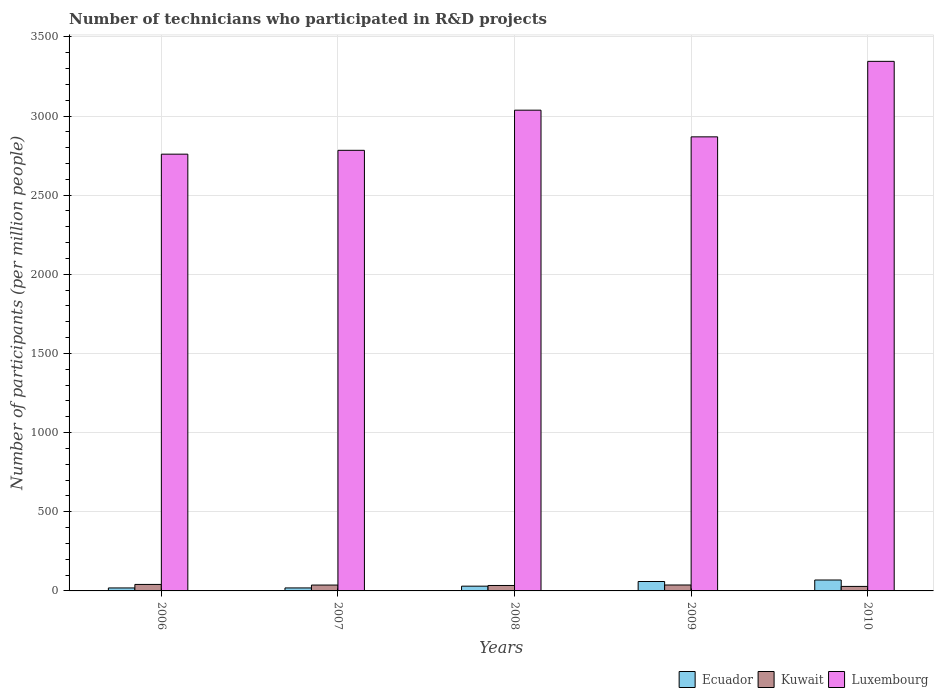How many groups of bars are there?
Provide a short and direct response. 5. What is the number of technicians who participated in R&D projects in Kuwait in 2010?
Offer a very short reply. 28.44. Across all years, what is the maximum number of technicians who participated in R&D projects in Kuwait?
Keep it short and to the point. 41.01. Across all years, what is the minimum number of technicians who participated in R&D projects in Ecuador?
Your response must be concise. 18.83. What is the total number of technicians who participated in R&D projects in Ecuador in the graph?
Your answer should be compact. 196.16. What is the difference between the number of technicians who participated in R&D projects in Luxembourg in 2007 and that in 2008?
Provide a short and direct response. -253.62. What is the difference between the number of technicians who participated in R&D projects in Ecuador in 2008 and the number of technicians who participated in R&D projects in Luxembourg in 2006?
Offer a very short reply. -2728.86. What is the average number of technicians who participated in R&D projects in Kuwait per year?
Provide a short and direct response. 35.67. In the year 2008, what is the difference between the number of technicians who participated in R&D projects in Kuwait and number of technicians who participated in R&D projects in Luxembourg?
Keep it short and to the point. -3002.45. What is the ratio of the number of technicians who participated in R&D projects in Kuwait in 2006 to that in 2007?
Keep it short and to the point. 1.11. Is the difference between the number of technicians who participated in R&D projects in Kuwait in 2008 and 2010 greater than the difference between the number of technicians who participated in R&D projects in Luxembourg in 2008 and 2010?
Provide a short and direct response. Yes. What is the difference between the highest and the second highest number of technicians who participated in R&D projects in Ecuador?
Give a very brief answer. 9.47. What is the difference between the highest and the lowest number of technicians who participated in R&D projects in Kuwait?
Offer a terse response. 12.58. Is the sum of the number of technicians who participated in R&D projects in Luxembourg in 2007 and 2008 greater than the maximum number of technicians who participated in R&D projects in Kuwait across all years?
Make the answer very short. Yes. What does the 3rd bar from the left in 2010 represents?
Make the answer very short. Luxembourg. What does the 1st bar from the right in 2010 represents?
Provide a succinct answer. Luxembourg. Is it the case that in every year, the sum of the number of technicians who participated in R&D projects in Luxembourg and number of technicians who participated in R&D projects in Ecuador is greater than the number of technicians who participated in R&D projects in Kuwait?
Provide a succinct answer. Yes. How many bars are there?
Your response must be concise. 15. Are all the bars in the graph horizontal?
Your response must be concise. No. How many years are there in the graph?
Your answer should be compact. 5. Are the values on the major ticks of Y-axis written in scientific E-notation?
Keep it short and to the point. No. Does the graph contain any zero values?
Your answer should be very brief. No. Where does the legend appear in the graph?
Ensure brevity in your answer.  Bottom right. What is the title of the graph?
Offer a very short reply. Number of technicians who participated in R&D projects. What is the label or title of the Y-axis?
Offer a terse response. Number of participants (per million people). What is the Number of participants (per million people) in Ecuador in 2006?
Your response must be concise. 18.83. What is the Number of participants (per million people) of Kuwait in 2006?
Offer a terse response. 41.01. What is the Number of participants (per million people) in Luxembourg in 2006?
Offer a terse response. 2758.91. What is the Number of participants (per million people) in Ecuador in 2007?
Provide a succinct answer. 18.94. What is the Number of participants (per million people) of Kuwait in 2007?
Your answer should be compact. 37.03. What is the Number of participants (per million people) in Luxembourg in 2007?
Provide a short and direct response. 2783.2. What is the Number of participants (per million people) in Ecuador in 2008?
Offer a very short reply. 30.05. What is the Number of participants (per million people) of Kuwait in 2008?
Provide a short and direct response. 34.38. What is the Number of participants (per million people) in Luxembourg in 2008?
Ensure brevity in your answer.  3036.82. What is the Number of participants (per million people) in Ecuador in 2009?
Offer a very short reply. 59.44. What is the Number of participants (per million people) of Kuwait in 2009?
Offer a very short reply. 37.48. What is the Number of participants (per million people) of Luxembourg in 2009?
Provide a short and direct response. 2868.27. What is the Number of participants (per million people) of Ecuador in 2010?
Offer a very short reply. 68.91. What is the Number of participants (per million people) in Kuwait in 2010?
Give a very brief answer. 28.44. What is the Number of participants (per million people) in Luxembourg in 2010?
Provide a short and direct response. 3345.22. Across all years, what is the maximum Number of participants (per million people) of Ecuador?
Your answer should be compact. 68.91. Across all years, what is the maximum Number of participants (per million people) in Kuwait?
Your response must be concise. 41.01. Across all years, what is the maximum Number of participants (per million people) in Luxembourg?
Ensure brevity in your answer.  3345.22. Across all years, what is the minimum Number of participants (per million people) of Ecuador?
Give a very brief answer. 18.83. Across all years, what is the minimum Number of participants (per million people) in Kuwait?
Provide a short and direct response. 28.44. Across all years, what is the minimum Number of participants (per million people) of Luxembourg?
Provide a succinct answer. 2758.91. What is the total Number of participants (per million people) of Ecuador in the graph?
Your answer should be very brief. 196.16. What is the total Number of participants (per million people) in Kuwait in the graph?
Provide a succinct answer. 178.34. What is the total Number of participants (per million people) in Luxembourg in the graph?
Offer a very short reply. 1.48e+04. What is the difference between the Number of participants (per million people) of Ecuador in 2006 and that in 2007?
Offer a terse response. -0.11. What is the difference between the Number of participants (per million people) in Kuwait in 2006 and that in 2007?
Provide a succinct answer. 3.98. What is the difference between the Number of participants (per million people) in Luxembourg in 2006 and that in 2007?
Keep it short and to the point. -24.29. What is the difference between the Number of participants (per million people) in Ecuador in 2006 and that in 2008?
Your answer should be compact. -11.22. What is the difference between the Number of participants (per million people) in Kuwait in 2006 and that in 2008?
Provide a short and direct response. 6.64. What is the difference between the Number of participants (per million people) in Luxembourg in 2006 and that in 2008?
Your response must be concise. -277.91. What is the difference between the Number of participants (per million people) in Ecuador in 2006 and that in 2009?
Offer a very short reply. -40.61. What is the difference between the Number of participants (per million people) of Kuwait in 2006 and that in 2009?
Your answer should be very brief. 3.53. What is the difference between the Number of participants (per million people) in Luxembourg in 2006 and that in 2009?
Ensure brevity in your answer.  -109.36. What is the difference between the Number of participants (per million people) in Ecuador in 2006 and that in 2010?
Offer a terse response. -50.08. What is the difference between the Number of participants (per million people) in Kuwait in 2006 and that in 2010?
Your answer should be compact. 12.58. What is the difference between the Number of participants (per million people) in Luxembourg in 2006 and that in 2010?
Provide a succinct answer. -586.31. What is the difference between the Number of participants (per million people) of Ecuador in 2007 and that in 2008?
Offer a terse response. -11.12. What is the difference between the Number of participants (per million people) of Kuwait in 2007 and that in 2008?
Provide a short and direct response. 2.65. What is the difference between the Number of participants (per million people) of Luxembourg in 2007 and that in 2008?
Provide a succinct answer. -253.62. What is the difference between the Number of participants (per million people) in Ecuador in 2007 and that in 2009?
Your answer should be compact. -40.5. What is the difference between the Number of participants (per million people) of Kuwait in 2007 and that in 2009?
Provide a succinct answer. -0.46. What is the difference between the Number of participants (per million people) in Luxembourg in 2007 and that in 2009?
Keep it short and to the point. -85.07. What is the difference between the Number of participants (per million people) of Ecuador in 2007 and that in 2010?
Provide a short and direct response. -49.97. What is the difference between the Number of participants (per million people) in Kuwait in 2007 and that in 2010?
Provide a short and direct response. 8.59. What is the difference between the Number of participants (per million people) of Luxembourg in 2007 and that in 2010?
Your answer should be very brief. -562.02. What is the difference between the Number of participants (per million people) in Ecuador in 2008 and that in 2009?
Offer a very short reply. -29.38. What is the difference between the Number of participants (per million people) of Kuwait in 2008 and that in 2009?
Make the answer very short. -3.11. What is the difference between the Number of participants (per million people) in Luxembourg in 2008 and that in 2009?
Your answer should be compact. 168.55. What is the difference between the Number of participants (per million people) in Ecuador in 2008 and that in 2010?
Your answer should be compact. -38.85. What is the difference between the Number of participants (per million people) in Kuwait in 2008 and that in 2010?
Offer a very short reply. 5.94. What is the difference between the Number of participants (per million people) of Luxembourg in 2008 and that in 2010?
Offer a very short reply. -308.39. What is the difference between the Number of participants (per million people) of Ecuador in 2009 and that in 2010?
Make the answer very short. -9.47. What is the difference between the Number of participants (per million people) in Kuwait in 2009 and that in 2010?
Your response must be concise. 9.05. What is the difference between the Number of participants (per million people) in Luxembourg in 2009 and that in 2010?
Keep it short and to the point. -476.95. What is the difference between the Number of participants (per million people) in Ecuador in 2006 and the Number of participants (per million people) in Kuwait in 2007?
Your answer should be very brief. -18.2. What is the difference between the Number of participants (per million people) of Ecuador in 2006 and the Number of participants (per million people) of Luxembourg in 2007?
Offer a very short reply. -2764.37. What is the difference between the Number of participants (per million people) in Kuwait in 2006 and the Number of participants (per million people) in Luxembourg in 2007?
Give a very brief answer. -2742.19. What is the difference between the Number of participants (per million people) of Ecuador in 2006 and the Number of participants (per million people) of Kuwait in 2008?
Your answer should be compact. -15.55. What is the difference between the Number of participants (per million people) in Ecuador in 2006 and the Number of participants (per million people) in Luxembourg in 2008?
Provide a succinct answer. -3018. What is the difference between the Number of participants (per million people) in Kuwait in 2006 and the Number of participants (per million people) in Luxembourg in 2008?
Your response must be concise. -2995.81. What is the difference between the Number of participants (per million people) in Ecuador in 2006 and the Number of participants (per million people) in Kuwait in 2009?
Make the answer very short. -18.65. What is the difference between the Number of participants (per million people) of Ecuador in 2006 and the Number of participants (per million people) of Luxembourg in 2009?
Your response must be concise. -2849.44. What is the difference between the Number of participants (per million people) in Kuwait in 2006 and the Number of participants (per million people) in Luxembourg in 2009?
Provide a short and direct response. -2827.26. What is the difference between the Number of participants (per million people) in Ecuador in 2006 and the Number of participants (per million people) in Kuwait in 2010?
Ensure brevity in your answer.  -9.61. What is the difference between the Number of participants (per million people) of Ecuador in 2006 and the Number of participants (per million people) of Luxembourg in 2010?
Keep it short and to the point. -3326.39. What is the difference between the Number of participants (per million people) of Kuwait in 2006 and the Number of participants (per million people) of Luxembourg in 2010?
Your answer should be very brief. -3304.21. What is the difference between the Number of participants (per million people) in Ecuador in 2007 and the Number of participants (per million people) in Kuwait in 2008?
Keep it short and to the point. -15.44. What is the difference between the Number of participants (per million people) of Ecuador in 2007 and the Number of participants (per million people) of Luxembourg in 2008?
Provide a succinct answer. -3017.89. What is the difference between the Number of participants (per million people) of Kuwait in 2007 and the Number of participants (per million people) of Luxembourg in 2008?
Keep it short and to the point. -2999.8. What is the difference between the Number of participants (per million people) of Ecuador in 2007 and the Number of participants (per million people) of Kuwait in 2009?
Offer a very short reply. -18.55. What is the difference between the Number of participants (per million people) of Ecuador in 2007 and the Number of participants (per million people) of Luxembourg in 2009?
Give a very brief answer. -2849.34. What is the difference between the Number of participants (per million people) of Kuwait in 2007 and the Number of participants (per million people) of Luxembourg in 2009?
Offer a terse response. -2831.24. What is the difference between the Number of participants (per million people) of Ecuador in 2007 and the Number of participants (per million people) of Kuwait in 2010?
Offer a terse response. -9.5. What is the difference between the Number of participants (per million people) of Ecuador in 2007 and the Number of participants (per million people) of Luxembourg in 2010?
Your answer should be compact. -3326.28. What is the difference between the Number of participants (per million people) in Kuwait in 2007 and the Number of participants (per million people) in Luxembourg in 2010?
Offer a terse response. -3308.19. What is the difference between the Number of participants (per million people) of Ecuador in 2008 and the Number of participants (per million people) of Kuwait in 2009?
Keep it short and to the point. -7.43. What is the difference between the Number of participants (per million people) of Ecuador in 2008 and the Number of participants (per million people) of Luxembourg in 2009?
Offer a very short reply. -2838.22. What is the difference between the Number of participants (per million people) in Kuwait in 2008 and the Number of participants (per million people) in Luxembourg in 2009?
Provide a succinct answer. -2833.89. What is the difference between the Number of participants (per million people) of Ecuador in 2008 and the Number of participants (per million people) of Kuwait in 2010?
Offer a terse response. 1.62. What is the difference between the Number of participants (per million people) in Ecuador in 2008 and the Number of participants (per million people) in Luxembourg in 2010?
Offer a very short reply. -3315.17. What is the difference between the Number of participants (per million people) of Kuwait in 2008 and the Number of participants (per million people) of Luxembourg in 2010?
Make the answer very short. -3310.84. What is the difference between the Number of participants (per million people) of Ecuador in 2009 and the Number of participants (per million people) of Kuwait in 2010?
Your response must be concise. 31. What is the difference between the Number of participants (per million people) of Ecuador in 2009 and the Number of participants (per million people) of Luxembourg in 2010?
Your answer should be compact. -3285.78. What is the difference between the Number of participants (per million people) in Kuwait in 2009 and the Number of participants (per million people) in Luxembourg in 2010?
Your response must be concise. -3307.74. What is the average Number of participants (per million people) in Ecuador per year?
Ensure brevity in your answer.  39.23. What is the average Number of participants (per million people) of Kuwait per year?
Provide a short and direct response. 35.67. What is the average Number of participants (per million people) in Luxembourg per year?
Keep it short and to the point. 2958.49. In the year 2006, what is the difference between the Number of participants (per million people) of Ecuador and Number of participants (per million people) of Kuwait?
Keep it short and to the point. -22.18. In the year 2006, what is the difference between the Number of participants (per million people) in Ecuador and Number of participants (per million people) in Luxembourg?
Provide a short and direct response. -2740.08. In the year 2006, what is the difference between the Number of participants (per million people) of Kuwait and Number of participants (per million people) of Luxembourg?
Your answer should be very brief. -2717.9. In the year 2007, what is the difference between the Number of participants (per million people) in Ecuador and Number of participants (per million people) in Kuwait?
Your response must be concise. -18.09. In the year 2007, what is the difference between the Number of participants (per million people) in Ecuador and Number of participants (per million people) in Luxembourg?
Provide a succinct answer. -2764.27. In the year 2007, what is the difference between the Number of participants (per million people) in Kuwait and Number of participants (per million people) in Luxembourg?
Provide a succinct answer. -2746.17. In the year 2008, what is the difference between the Number of participants (per million people) of Ecuador and Number of participants (per million people) of Kuwait?
Your response must be concise. -4.32. In the year 2008, what is the difference between the Number of participants (per million people) of Ecuador and Number of participants (per million people) of Luxembourg?
Make the answer very short. -3006.77. In the year 2008, what is the difference between the Number of participants (per million people) in Kuwait and Number of participants (per million people) in Luxembourg?
Offer a very short reply. -3002.45. In the year 2009, what is the difference between the Number of participants (per million people) of Ecuador and Number of participants (per million people) of Kuwait?
Your answer should be compact. 21.95. In the year 2009, what is the difference between the Number of participants (per million people) of Ecuador and Number of participants (per million people) of Luxembourg?
Make the answer very short. -2808.83. In the year 2009, what is the difference between the Number of participants (per million people) in Kuwait and Number of participants (per million people) in Luxembourg?
Offer a terse response. -2830.79. In the year 2010, what is the difference between the Number of participants (per million people) in Ecuador and Number of participants (per million people) in Kuwait?
Your answer should be compact. 40.47. In the year 2010, what is the difference between the Number of participants (per million people) in Ecuador and Number of participants (per million people) in Luxembourg?
Your answer should be compact. -3276.31. In the year 2010, what is the difference between the Number of participants (per million people) of Kuwait and Number of participants (per million people) of Luxembourg?
Keep it short and to the point. -3316.78. What is the ratio of the Number of participants (per million people) of Kuwait in 2006 to that in 2007?
Your answer should be very brief. 1.11. What is the ratio of the Number of participants (per million people) in Ecuador in 2006 to that in 2008?
Give a very brief answer. 0.63. What is the ratio of the Number of participants (per million people) of Kuwait in 2006 to that in 2008?
Offer a terse response. 1.19. What is the ratio of the Number of participants (per million people) of Luxembourg in 2006 to that in 2008?
Provide a short and direct response. 0.91. What is the ratio of the Number of participants (per million people) of Ecuador in 2006 to that in 2009?
Your response must be concise. 0.32. What is the ratio of the Number of participants (per million people) of Kuwait in 2006 to that in 2009?
Keep it short and to the point. 1.09. What is the ratio of the Number of participants (per million people) of Luxembourg in 2006 to that in 2009?
Make the answer very short. 0.96. What is the ratio of the Number of participants (per million people) in Ecuador in 2006 to that in 2010?
Ensure brevity in your answer.  0.27. What is the ratio of the Number of participants (per million people) in Kuwait in 2006 to that in 2010?
Offer a terse response. 1.44. What is the ratio of the Number of participants (per million people) in Luxembourg in 2006 to that in 2010?
Make the answer very short. 0.82. What is the ratio of the Number of participants (per million people) in Ecuador in 2007 to that in 2008?
Provide a succinct answer. 0.63. What is the ratio of the Number of participants (per million people) of Kuwait in 2007 to that in 2008?
Offer a terse response. 1.08. What is the ratio of the Number of participants (per million people) in Luxembourg in 2007 to that in 2008?
Your response must be concise. 0.92. What is the ratio of the Number of participants (per million people) in Ecuador in 2007 to that in 2009?
Keep it short and to the point. 0.32. What is the ratio of the Number of participants (per million people) of Kuwait in 2007 to that in 2009?
Make the answer very short. 0.99. What is the ratio of the Number of participants (per million people) of Luxembourg in 2007 to that in 2009?
Your response must be concise. 0.97. What is the ratio of the Number of participants (per million people) of Ecuador in 2007 to that in 2010?
Your answer should be very brief. 0.27. What is the ratio of the Number of participants (per million people) in Kuwait in 2007 to that in 2010?
Ensure brevity in your answer.  1.3. What is the ratio of the Number of participants (per million people) in Luxembourg in 2007 to that in 2010?
Provide a short and direct response. 0.83. What is the ratio of the Number of participants (per million people) in Ecuador in 2008 to that in 2009?
Make the answer very short. 0.51. What is the ratio of the Number of participants (per million people) of Kuwait in 2008 to that in 2009?
Make the answer very short. 0.92. What is the ratio of the Number of participants (per million people) in Luxembourg in 2008 to that in 2009?
Provide a short and direct response. 1.06. What is the ratio of the Number of participants (per million people) in Ecuador in 2008 to that in 2010?
Ensure brevity in your answer.  0.44. What is the ratio of the Number of participants (per million people) in Kuwait in 2008 to that in 2010?
Your answer should be compact. 1.21. What is the ratio of the Number of participants (per million people) in Luxembourg in 2008 to that in 2010?
Ensure brevity in your answer.  0.91. What is the ratio of the Number of participants (per million people) of Ecuador in 2009 to that in 2010?
Offer a terse response. 0.86. What is the ratio of the Number of participants (per million people) of Kuwait in 2009 to that in 2010?
Your answer should be very brief. 1.32. What is the ratio of the Number of participants (per million people) in Luxembourg in 2009 to that in 2010?
Make the answer very short. 0.86. What is the difference between the highest and the second highest Number of participants (per million people) in Ecuador?
Keep it short and to the point. 9.47. What is the difference between the highest and the second highest Number of participants (per million people) in Kuwait?
Ensure brevity in your answer.  3.53. What is the difference between the highest and the second highest Number of participants (per million people) in Luxembourg?
Your answer should be compact. 308.39. What is the difference between the highest and the lowest Number of participants (per million people) of Ecuador?
Offer a very short reply. 50.08. What is the difference between the highest and the lowest Number of participants (per million people) of Kuwait?
Your response must be concise. 12.58. What is the difference between the highest and the lowest Number of participants (per million people) in Luxembourg?
Your answer should be very brief. 586.31. 